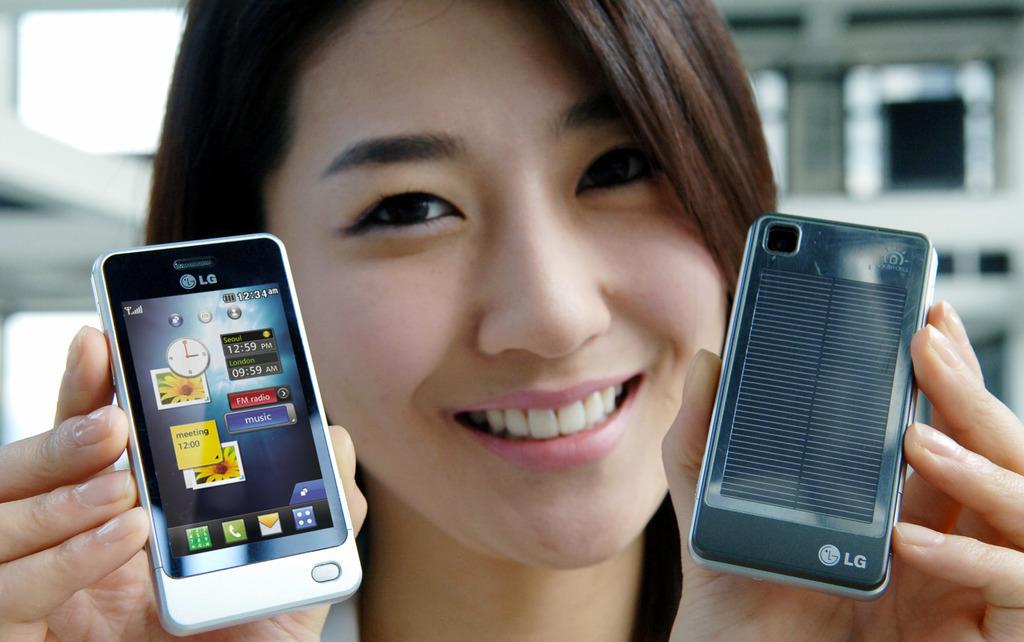What is the phone brand?
Make the answer very short. Lg. What time is the meeting?
Make the answer very short. 12:00. 